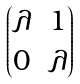<formula> <loc_0><loc_0><loc_500><loc_500>\begin{pmatrix} \lambda & 1 \\ 0 & \lambda \end{pmatrix}</formula> 